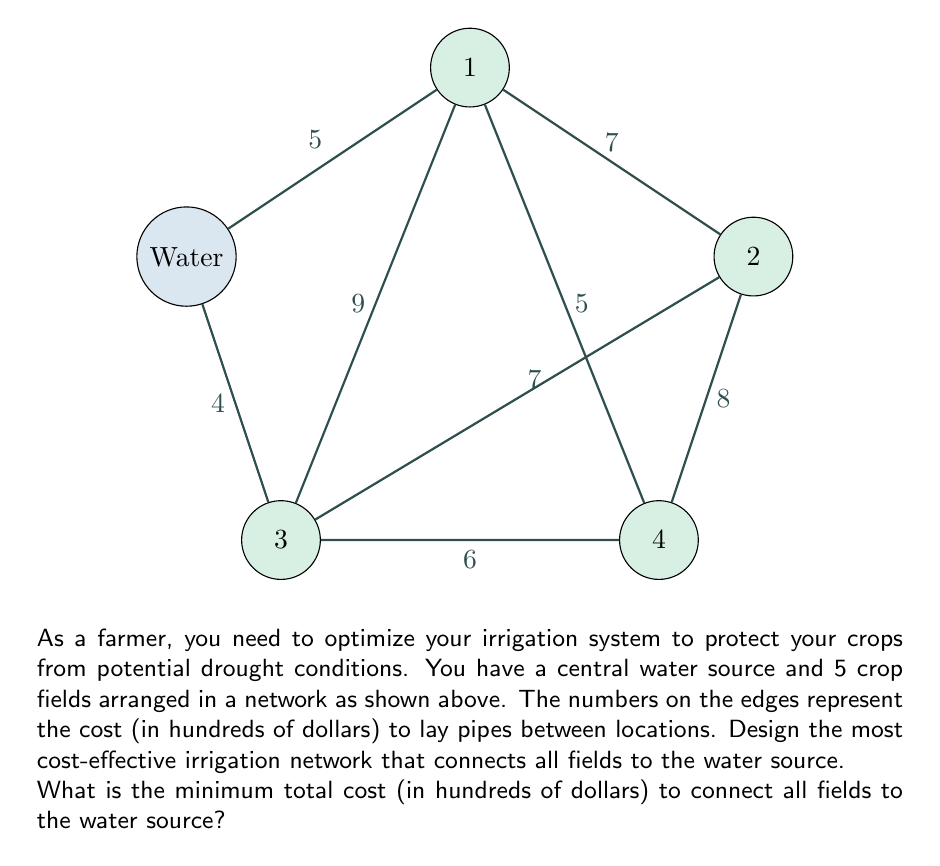Teach me how to tackle this problem. To solve this problem, we can use the concept of a minimum spanning tree from network topology. Here's a step-by-step approach:

1) First, we need to identify all possible connections and their costs:
   Water-1: 5, Water-3: 4, 1-2: 7, 1-3: 9, 1-4: 5, 2-3: 7, 2-4: 8, 3-4: 6

2) We'll use Kruskal's algorithm to find the minimum spanning tree:

   a) Sort the edges by cost in ascending order:
      Water-3: 4, Water-1: 5, 1-4: 5, 3-4: 6, 1-2: 7, 2-3: 7, 2-4: 8, 1-3: 9

   b) Add edges to our solution, skipping any that would create a cycle:
      - Add Water-3 (cost: 4)
      - Add Water-1 (cost: 5)
      - Add 1-4 (cost: 5)
      - Add 3-4 (cost: 6)
      - Skip 1-2 (would create a cycle)
      - Add 2-3 (cost: 7)

3) Our minimum spanning tree is complete, connecting all nodes with 5 edges.

4) Sum the costs of the selected edges:
   $4 + 5 + 5 + 6 + 7 = 27$

Therefore, the minimum total cost to connect all fields to the water source is 27 hundred dollars, or $2,700.
Answer: 27 